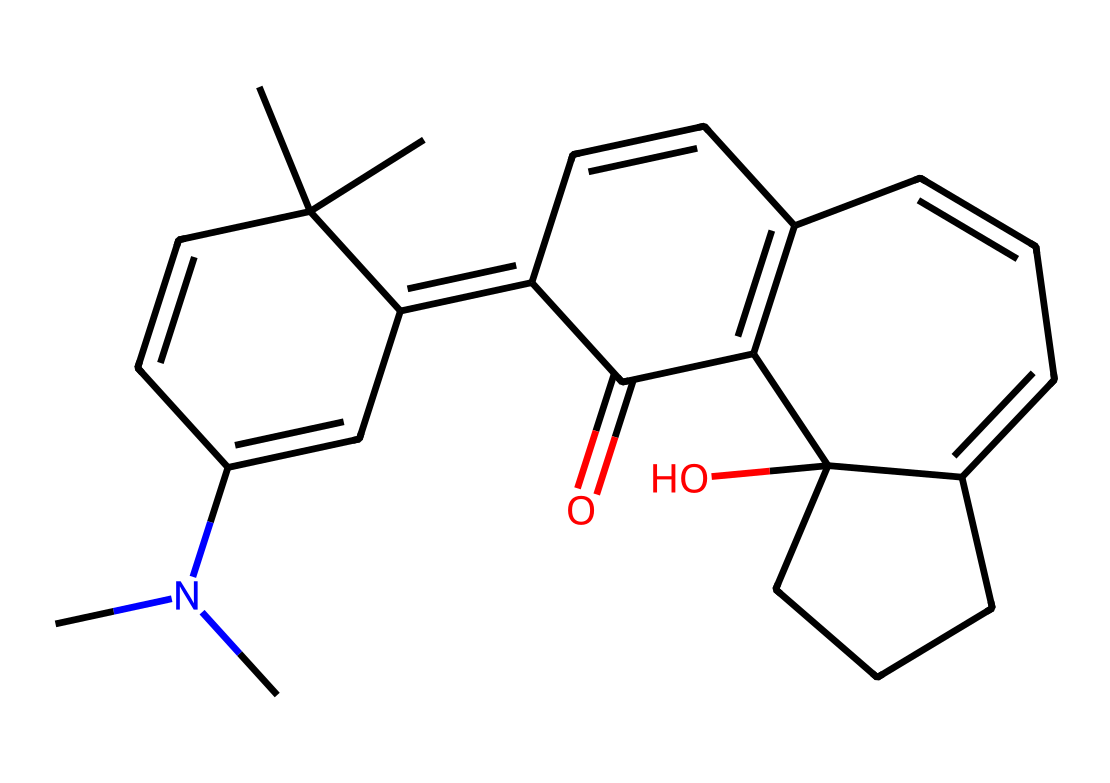How many rings are present in this spiropyran compound? The structure contains four distinct rings represented in the SMILES notation. The connected carbon atoms suggest multiple cyclic structures. Counting the distinct rings gives us four.
Answer: four What is the functional group attached to the spiropyran structure? In the provided SMILES, the presence of -O indicates that there is a hydroxyl (alcohol) functional group in the spiropyran structure, which is important for its reactivity and properties.
Answer: hydroxyl What is the oxidation state of the carbon in the carbonyl group? The carbonyl group (-C=O) indicates that the carbon atom in this position is in the oxidation state of +2 due to the double bond with oxygen, which is more electronegative and thus increases the carbon's oxidation state.
Answer: +2 How does the structure of this spiropyran contribute to its photochromic properties? The interconnected cyclic and double bond structure allows for a conformational change upon UV light exposure, transforming it from one isomeric form to another, which is essential for photochromic behavior.
Answer: conformational change What is the total number of carbon atoms present in the spiropyran compound? By carefully analyzing the SMILES string, the total count of carbon atoms is determined to be 24, as each 'C' represents a carbon atom and others implied through bonding.
Answer: 24 